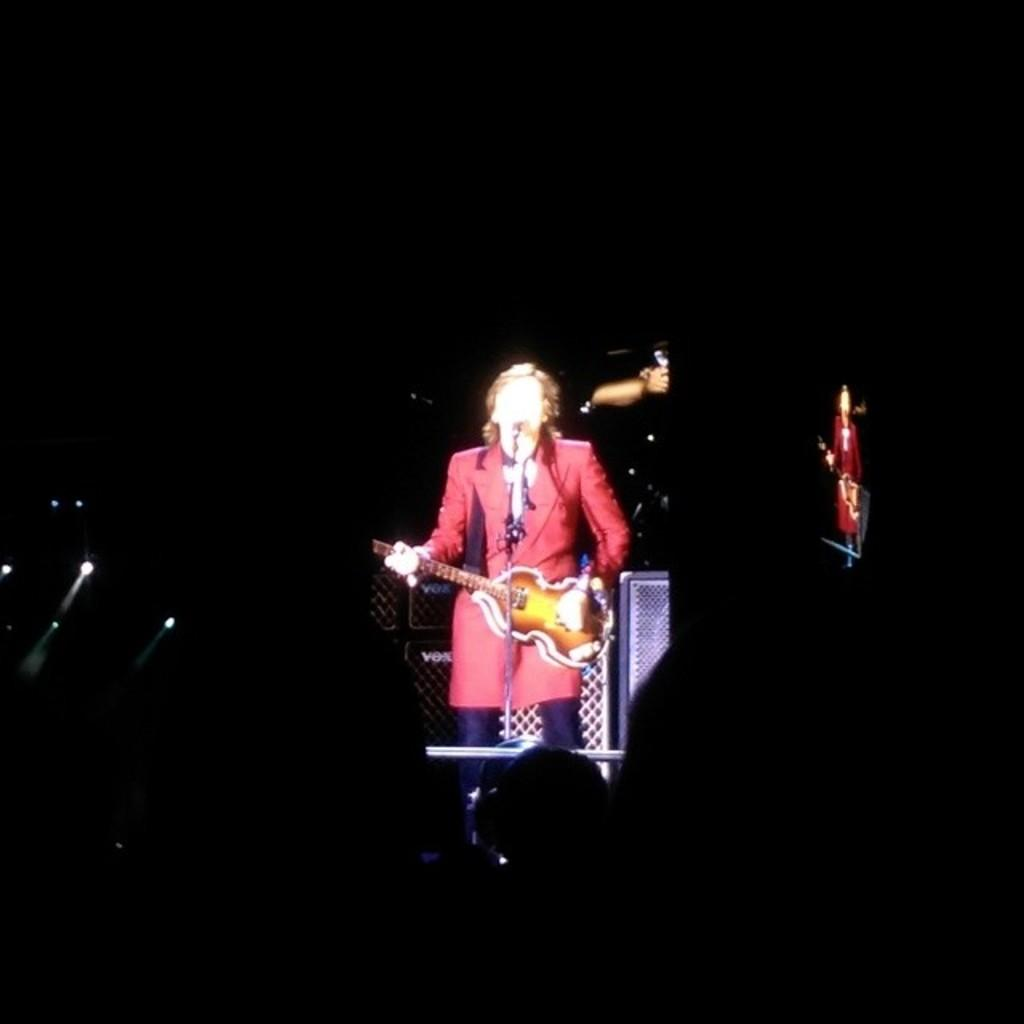What is the person in the picture doing? The person is playing a guitar. How is the person holding the guitar? The person is holding the guitar in her hands. What other object can be seen in the image related to the person's activity? There is a microphone in the image. What might the person be using to support the guitar or other equipment? There is a stand in the image. What color is the crayon being used by the person in the image? There is no crayon present in the image. Is the flame visible in the image affecting the person's performance? There is no flame present in the image. 